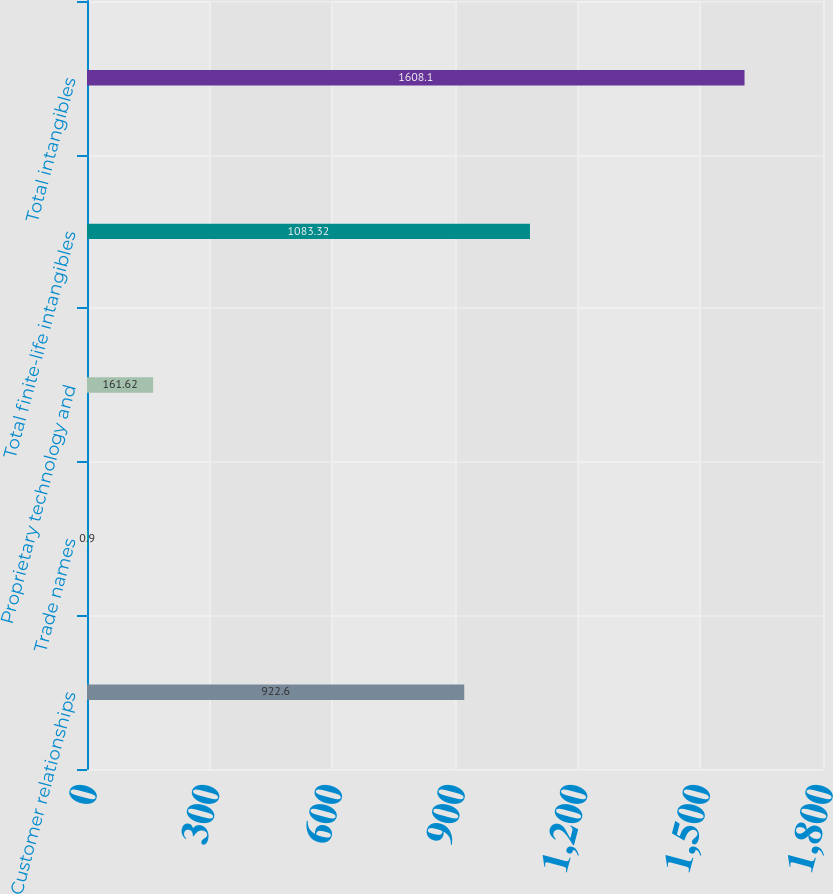<chart> <loc_0><loc_0><loc_500><loc_500><bar_chart><fcel>Customer relationships<fcel>Trade names<fcel>Proprietary technology and<fcel>Total finite-life intangibles<fcel>Total intangibles<nl><fcel>922.6<fcel>0.9<fcel>161.62<fcel>1083.32<fcel>1608.1<nl></chart> 